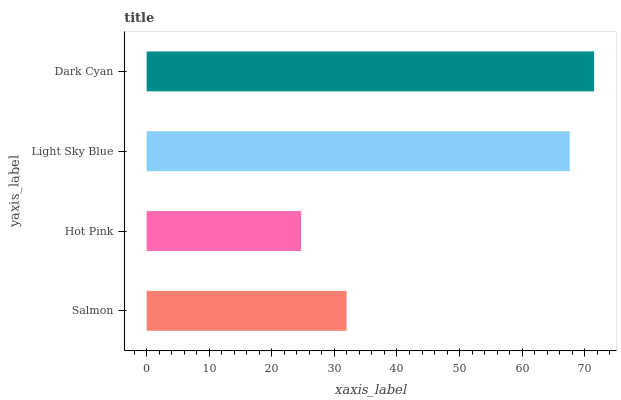Is Hot Pink the minimum?
Answer yes or no. Yes. Is Dark Cyan the maximum?
Answer yes or no. Yes. Is Light Sky Blue the minimum?
Answer yes or no. No. Is Light Sky Blue the maximum?
Answer yes or no. No. Is Light Sky Blue greater than Hot Pink?
Answer yes or no. Yes. Is Hot Pink less than Light Sky Blue?
Answer yes or no. Yes. Is Hot Pink greater than Light Sky Blue?
Answer yes or no. No. Is Light Sky Blue less than Hot Pink?
Answer yes or no. No. Is Light Sky Blue the high median?
Answer yes or no. Yes. Is Salmon the low median?
Answer yes or no. Yes. Is Salmon the high median?
Answer yes or no. No. Is Light Sky Blue the low median?
Answer yes or no. No. 